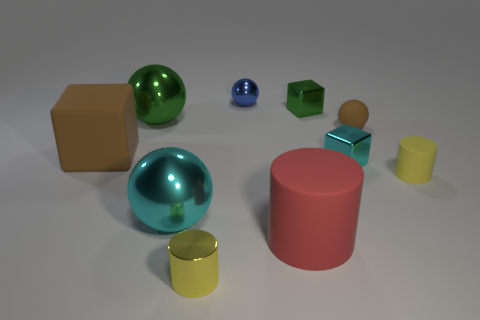Subtract all balls. How many objects are left? 6 Add 6 large cyan metallic spheres. How many large cyan metallic spheres are left? 7 Add 8 tiny blue spheres. How many tiny blue spheres exist? 9 Subtract 1 blue spheres. How many objects are left? 9 Subtract all small green matte spheres. Subtract all red matte things. How many objects are left? 9 